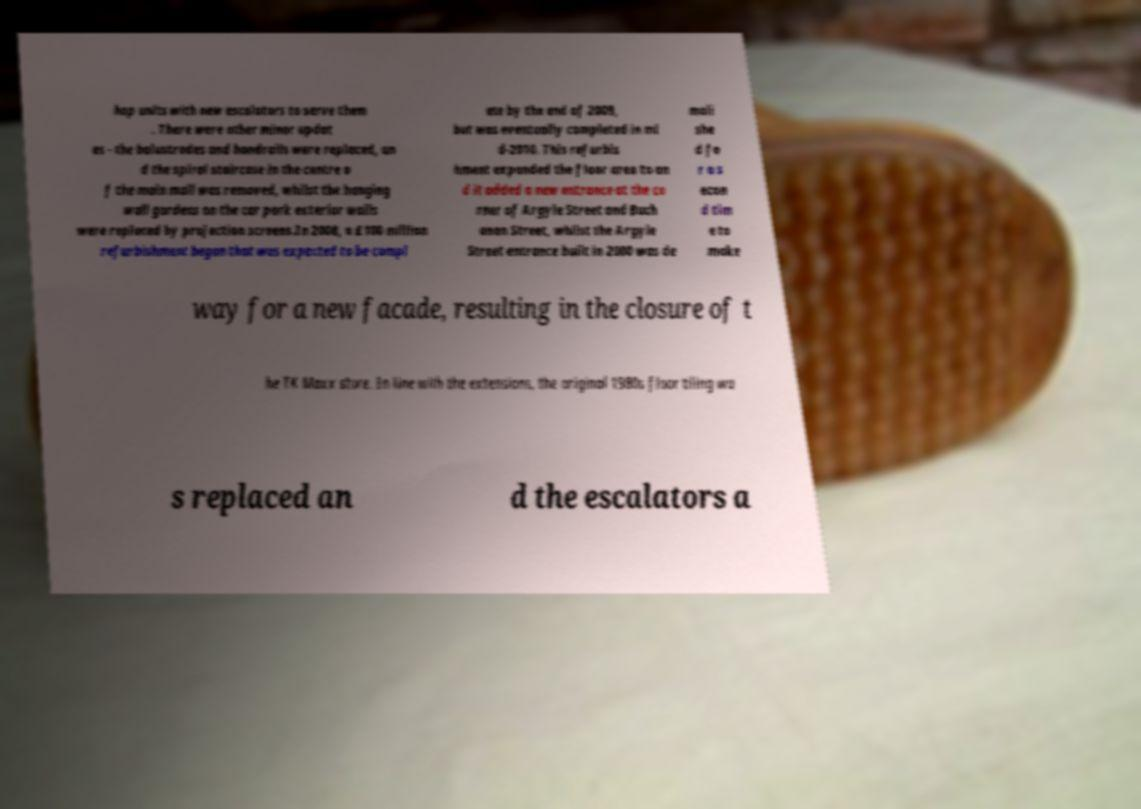Please read and relay the text visible in this image. What does it say? hop units with new escalators to serve them . There were other minor updat es - the balustrades and handrails were replaced, an d the spiral staircase in the centre o f the main mall was removed, whilst the hanging wall gardens on the car park exterior walls were replaced by projection screens.In 2008, a £100 million refurbishment began that was expected to be compl ete by the end of 2009, but was eventually completed in mi d-2010. This refurbis hment expanded the floor area to an d it added a new entrance at the co rner of Argyle Street and Buch anan Street, whilst the Argyle Street entrance built in 2000 was de moli she d fo r a s econ d tim e to make way for a new facade, resulting in the closure of t he TK Maxx store. In line with the extensions, the original 1980s floor tiling wa s replaced an d the escalators a 